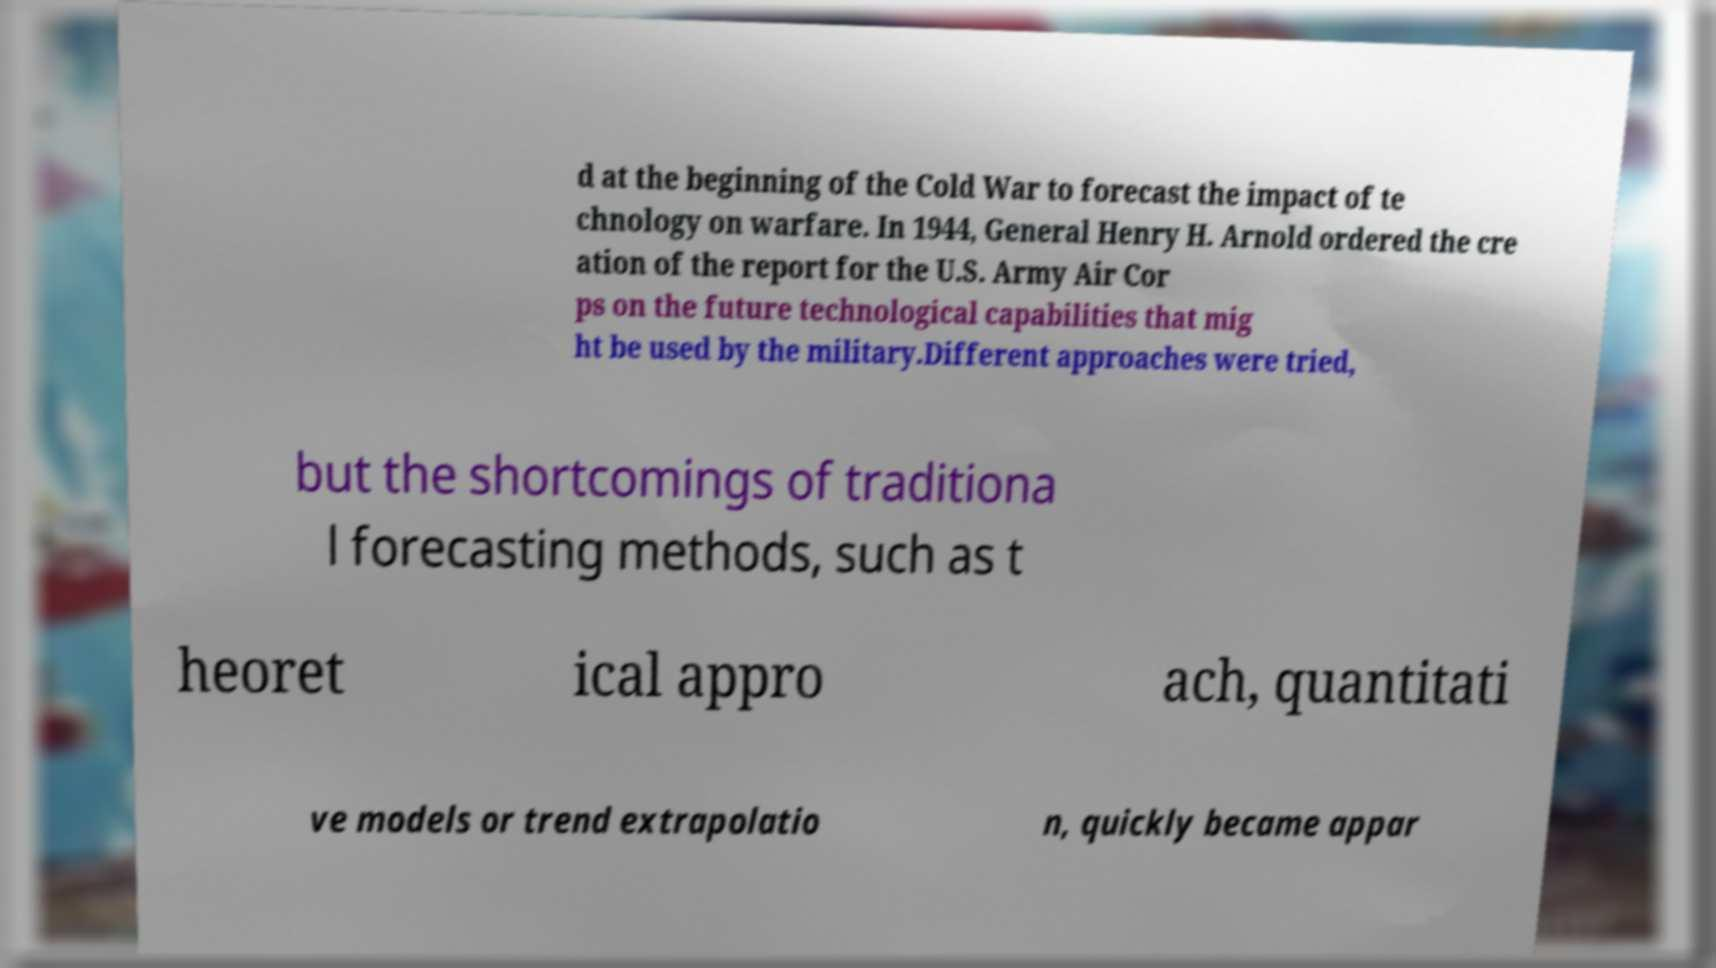Can you accurately transcribe the text from the provided image for me? d at the beginning of the Cold War to forecast the impact of te chnology on warfare. In 1944, General Henry H. Arnold ordered the cre ation of the report for the U.S. Army Air Cor ps on the future technological capabilities that mig ht be used by the military.Different approaches were tried, but the shortcomings of traditiona l forecasting methods, such as t heoret ical appro ach, quantitati ve models or trend extrapolatio n, quickly became appar 